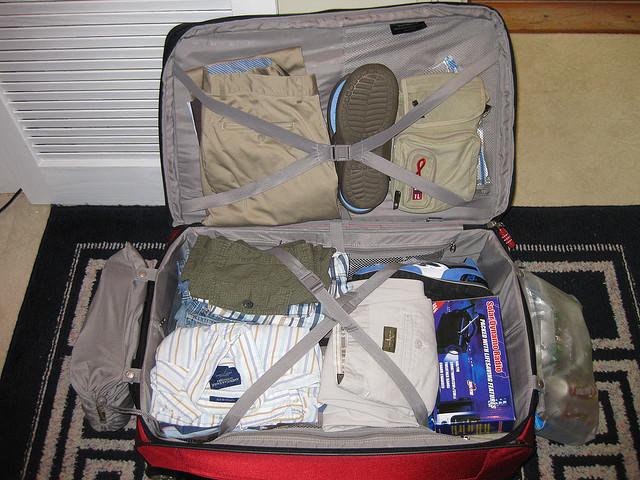Where are the shoes?
Short answer required. In suitcase. What is in the suitcase?
Be succinct. Clothes. How many pairs  of pants are visible?
Write a very short answer. 2. What is the luggage on?
Keep it brief. Floor. 